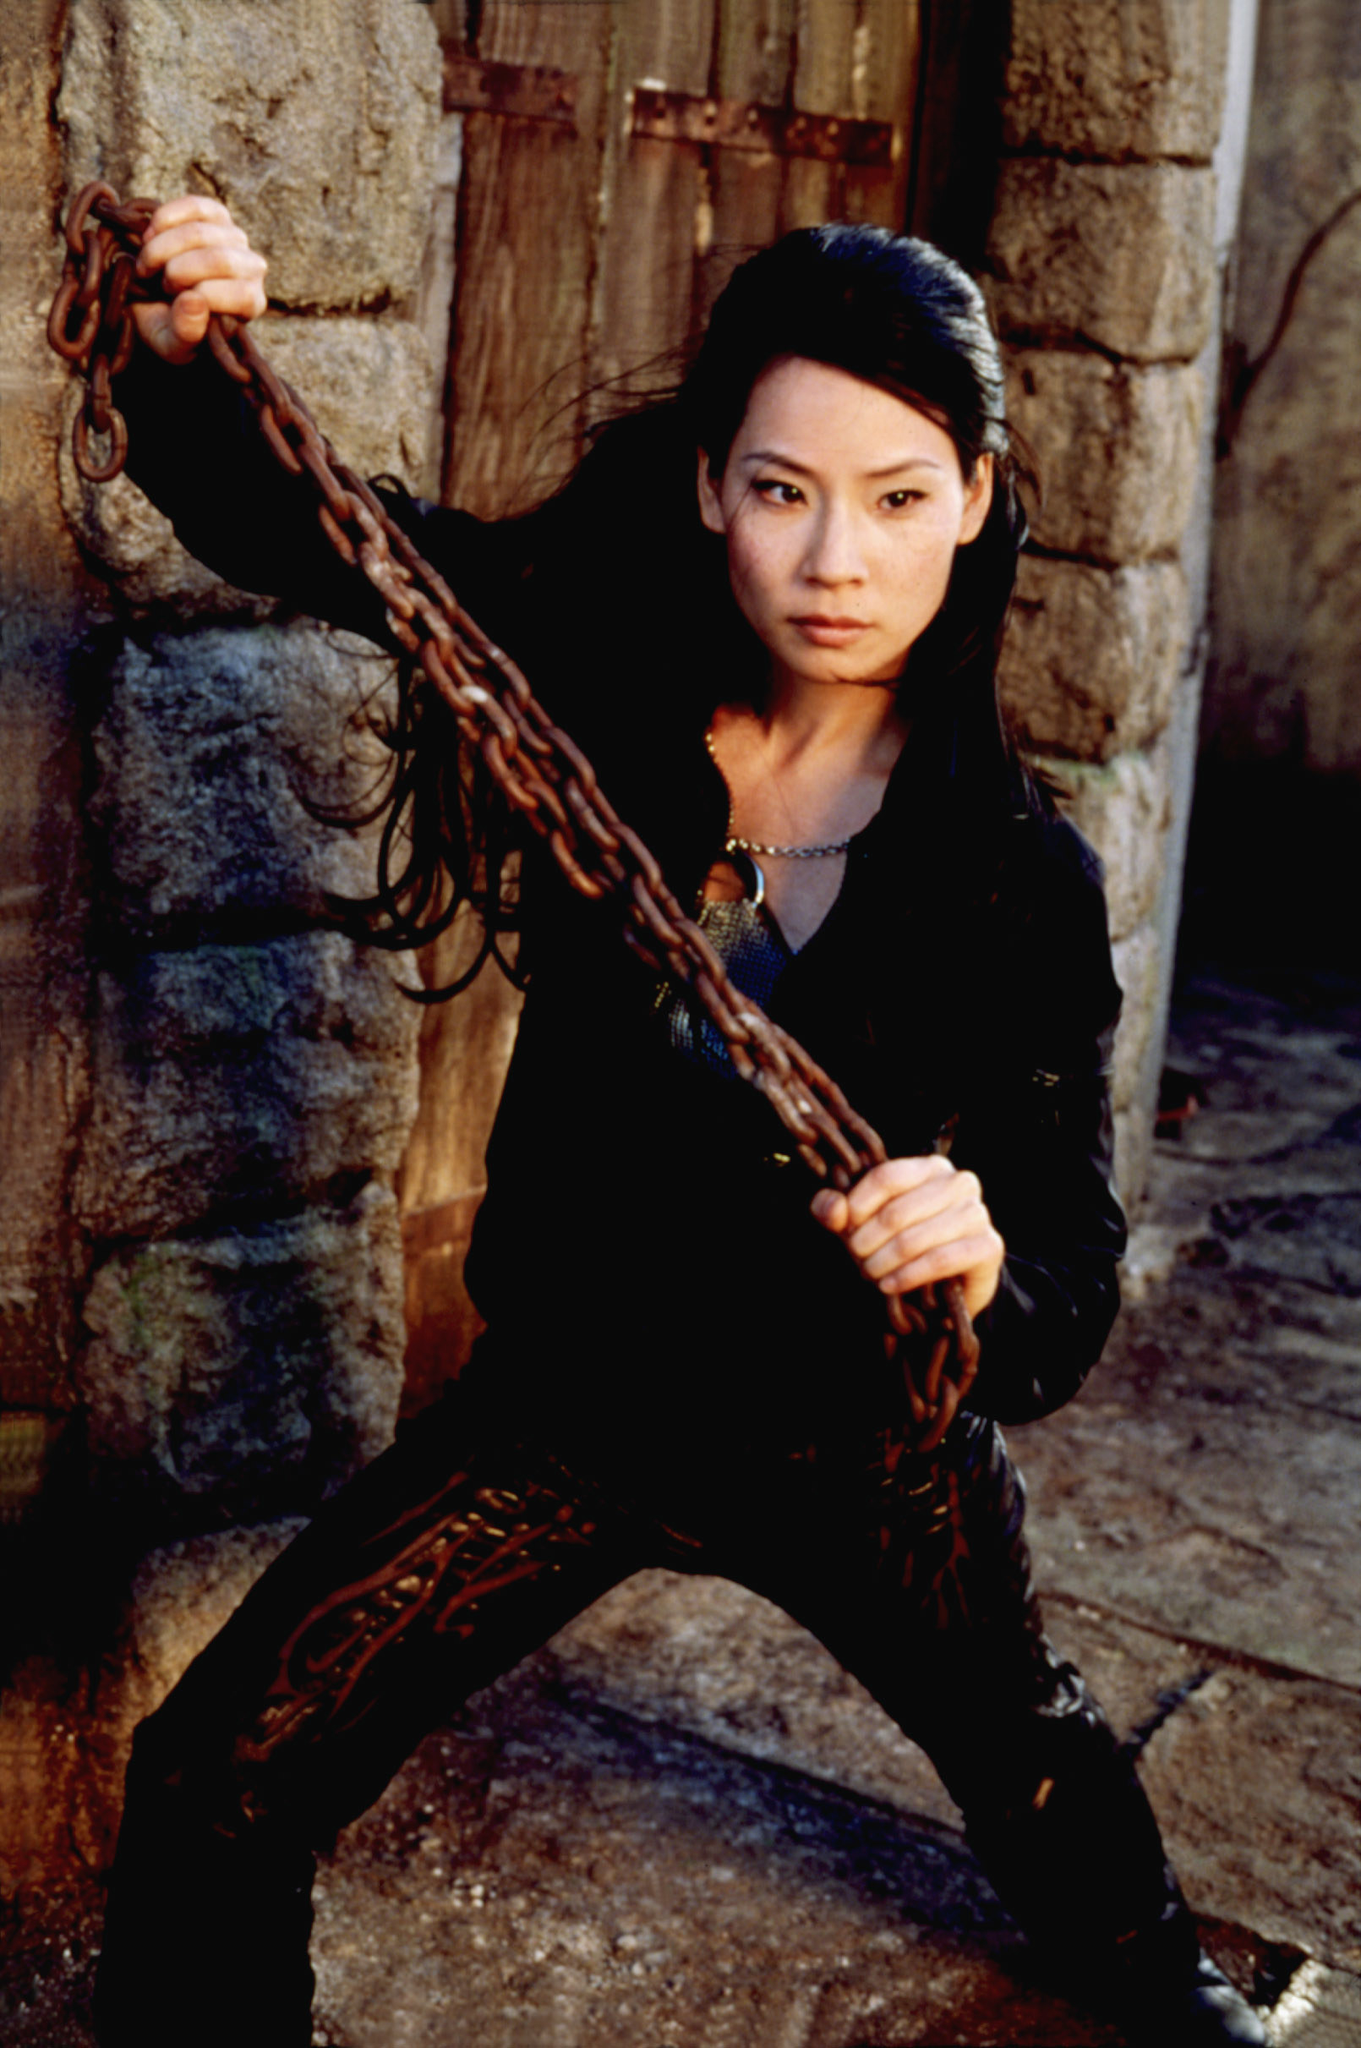What is happening in this image? In the image, a female character is captured in a moment of readiness. She appears alert and prepared for confrontation, gripping a chain firmly with one hand while maintaining a controlled yet intense pose. Can you describe her attire in more detail? Certainly! The character is wearing a fitted black jacket that highlights her form and black pants with intricate details. Around her neck, she wears a vivid red necklace that stands out against the darker tones of her clothing. The entire outfit suggests a blend of fashion and functionality, suitable for action or combat scenarios. How does her posture contribute to the overall mood of the image? Her posture greatly enhances the mood of the image. With her left hand gripping the chain and her right hand on her hip, she exudes a sense of readiness and control. Her slightly bent knees and the tension in her upper body suggest that she is prepared for immediate action. This combination of physical elements creates an atmosphere of suspense and anticipation. Imagine this image is part of a fantasy story. What role would this character play? In a fantasy story, this character could be envisioned as an elite warrior or guardian of a mystical realm. Tasked with protecting a sacred artifact or secret, she uses her combat skills and intelligence to fend off malevolent forces. Her strong and determined demeanor makes her a formidable protector, earning her the respect and admiration of those she defends. The chain could symbolize a magical weapon bound to her by an ancient vow, unleashing supernatural powers when wielded in battle. 